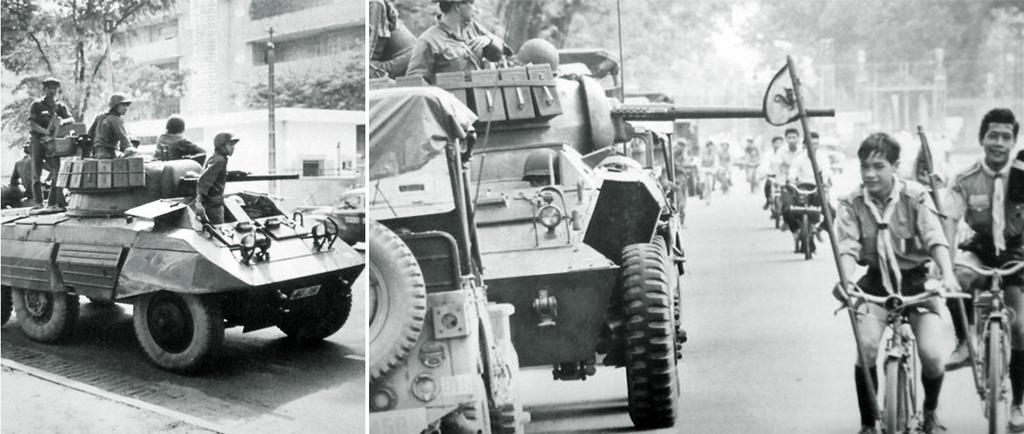Can you describe this image briefly? In this, this is a collage picture where we can see a tank and persons on it and background we can see buildings, trees, pole here in this picture we can see some persons riding bicycle, bikes. 